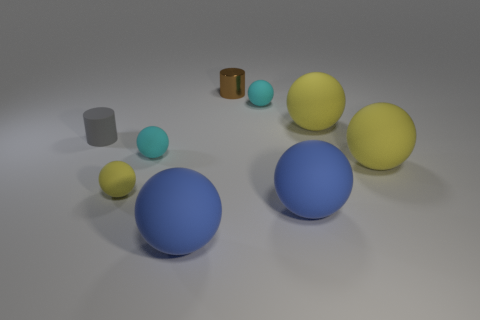Are there any patterns or symmetry in how the objects are arranged? The objects do not exhibit a clear pattern or symmetry. They are placed somewhat randomly with variations in distance and angles relative to each other. 